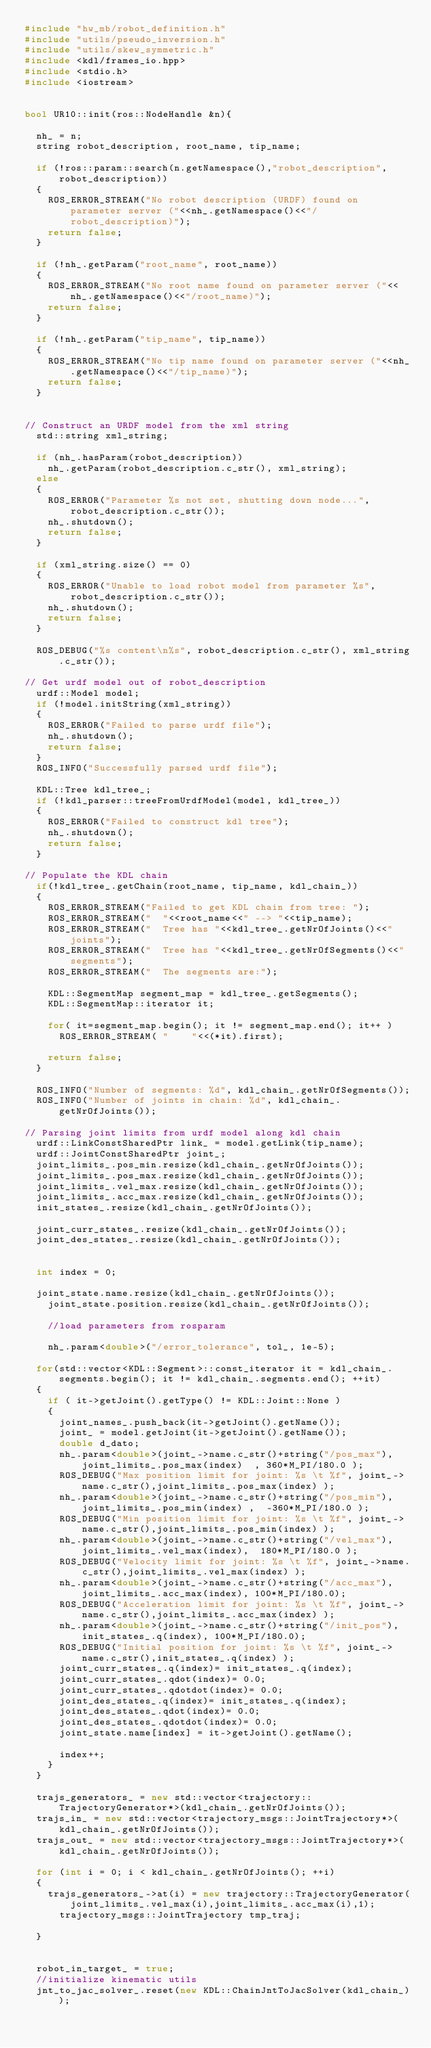<code> <loc_0><loc_0><loc_500><loc_500><_C++_>#include "hw_mb/robot_definition.h"
#include "utils/pseudo_inversion.h"
#include "utils/skew_symmetric.h"
#include <kdl/frames_io.hpp>
#include <stdio.h>
#include <iostream>


bool UR10::init(ros::NodeHandle &n){

	nh_ = n;
	string robot_description, root_name, tip_name;

	if (!ros::param::search(n.getNamespace(),"robot_description", robot_description))
	{
		ROS_ERROR_STREAM("No robot description (URDF) found on parameter server ("<<nh_.getNamespace()<<"/robot_description)");
		return false;
	}

	if (!nh_.getParam("root_name", root_name))
	{
		ROS_ERROR_STREAM("No root name found on parameter server ("<<nh_.getNamespace()<<"/root_name)");
		return false;
	}

	if (!nh_.getParam("tip_name", tip_name))
	{
		ROS_ERROR_STREAM("No tip name found on parameter server ("<<nh_.getNamespace()<<"/tip_name)");
		return false;
	}


// Construct an URDF model from the xml string
	std::string xml_string;

	if (nh_.hasParam(robot_description))
		nh_.getParam(robot_description.c_str(), xml_string);
	else
	{
		ROS_ERROR("Parameter %s not set, shutting down node...", robot_description.c_str());
		nh_.shutdown();
		return false;
	}

	if (xml_string.size() == 0)
	{
		ROS_ERROR("Unable to load robot model from parameter %s",robot_description.c_str());
		nh_.shutdown();
		return false;
	}

	ROS_DEBUG("%s content\n%s", robot_description.c_str(), xml_string.c_str());

// Get urdf model out of robot_description
	urdf::Model model;
	if (!model.initString(xml_string))
	{
		ROS_ERROR("Failed to parse urdf file");
		nh_.shutdown();
		return false;
	}
	ROS_INFO("Successfully parsed urdf file");

	KDL::Tree kdl_tree_;
	if (!kdl_parser::treeFromUrdfModel(model, kdl_tree_))
	{
		ROS_ERROR("Failed to construct kdl tree");
		nh_.shutdown();
		return false;
	}

// Populate the KDL chain
	if(!kdl_tree_.getChain(root_name, tip_name, kdl_chain_))
	{
		ROS_ERROR_STREAM("Failed to get KDL chain from tree: ");
		ROS_ERROR_STREAM("  "<<root_name<<" --> "<<tip_name);
		ROS_ERROR_STREAM("  Tree has "<<kdl_tree_.getNrOfJoints()<<" joints");
		ROS_ERROR_STREAM("  Tree has "<<kdl_tree_.getNrOfSegments()<<" segments");
		ROS_ERROR_STREAM("  The segments are:");

		KDL::SegmentMap segment_map = kdl_tree_.getSegments();
		KDL::SegmentMap::iterator it;

		for( it=segment_map.begin(); it != segment_map.end(); it++ )
			ROS_ERROR_STREAM( "    "<<(*it).first);

		return false;
	}

	ROS_INFO("Number of segments: %d", kdl_chain_.getNrOfSegments());
	ROS_INFO("Number of joints in chain: %d", kdl_chain_.getNrOfJoints());

// Parsing joint limits from urdf model along kdl chain
	urdf::LinkConstSharedPtr link_ = model.getLink(tip_name);
	urdf::JointConstSharedPtr joint_;
	joint_limits_.pos_min.resize(kdl_chain_.getNrOfJoints());
	joint_limits_.pos_max.resize(kdl_chain_.getNrOfJoints());
	joint_limits_.vel_max.resize(kdl_chain_.getNrOfJoints());
	joint_limits_.acc_max.resize(kdl_chain_.getNrOfJoints());
	init_states_.resize(kdl_chain_.getNrOfJoints());

	joint_curr_states_.resize(kdl_chain_.getNrOfJoints());
	joint_des_states_.resize(kdl_chain_.getNrOfJoints());


	int index = 0;

	joint_state.name.resize(kdl_chain_.getNrOfJoints());
    joint_state.position.resize(kdl_chain_.getNrOfJoints());

    //load parameters from rosparam

    nh_.param<double>("/error_tolerance", tol_, 1e-5);

	for(std::vector<KDL::Segment>::const_iterator it = kdl_chain_.segments.begin(); it != kdl_chain_.segments.end(); ++it)
	{
		if ( it->getJoint().getType() != KDL::Joint::None )
		{
			joint_names_.push_back(it->getJoint().getName());
			joint_ = model.getJoint(it->getJoint().getName()); 
			double d_dato;
			nh_.param<double>(joint_->name.c_str()+string("/pos_max"),joint_limits_.pos_max(index)  , 360*M_PI/180.0 );
			ROS_DEBUG("Max position limit for joint: %s \t %f", joint_->name.c_str(),joint_limits_.pos_max(index) );
			nh_.param<double>(joint_->name.c_str()+string("/pos_min"),joint_limits_.pos_min(index) ,  -360*M_PI/180.0 );
			ROS_DEBUG("Min position limit for joint: %s \t %f", joint_->name.c_str(),joint_limits_.pos_min(index) );
			nh_.param<double>(joint_->name.c_str()+string("/vel_max"),joint_limits_.vel_max(index),  180*M_PI/180.0 );
			ROS_DEBUG("Velocity limit for joint: %s \t %f", joint_->name.c_str(),joint_limits_.vel_max(index) );
			nh_.param<double>(joint_->name.c_str()+string("/acc_max"), joint_limits_.acc_max(index), 100*M_PI/180.0);
			ROS_DEBUG("Acceleration limit for joint: %s \t %f", joint_->name.c_str(),joint_limits_.acc_max(index) );
			nh_.param<double>(joint_->name.c_str()+string("/init_pos"), init_states_.q(index), 100*M_PI/180.0);
			ROS_DEBUG("Initial position for joint: %s \t %f", joint_->name.c_str(),init_states_.q(index) );
			joint_curr_states_.q(index)= init_states_.q(index);
			joint_curr_states_.qdot(index)= 0.0;
			joint_curr_states_.qdotdot(index)= 0.0;
			joint_des_states_.q(index)= init_states_.q(index);
			joint_des_states_.qdot(index)= 0.0;
			joint_des_states_.qdotdot(index)= 0.0;
			joint_state.name[index] = it->getJoint().getName();

			index++;
		}
	}

	trajs_generators_ = new std::vector<trajectory::TrajectoryGenerator*>(kdl_chain_.getNrOfJoints());
	trajs_in_ = new std::vector<trajectory_msgs::JointTrajectory*>(kdl_chain_.getNrOfJoints());
	trajs_out_ = new std::vector<trajectory_msgs::JointTrajectory*>(kdl_chain_.getNrOfJoints());

	for (int i = 0; i < kdl_chain_.getNrOfJoints(); ++i)
	{   
		trajs_generators_->at(i) = new trajectory::TrajectoryGenerator(joint_limits_.vel_max(i),joint_limits_.acc_max(i),1);
	    trajectory_msgs::JointTrajectory tmp_traj;

	}


	robot_in_target_ = true;
	//initialize kinematic utils
	jnt_to_jac_solver_.reset(new KDL::ChainJntToJacSolver(kdl_chain_));</code> 